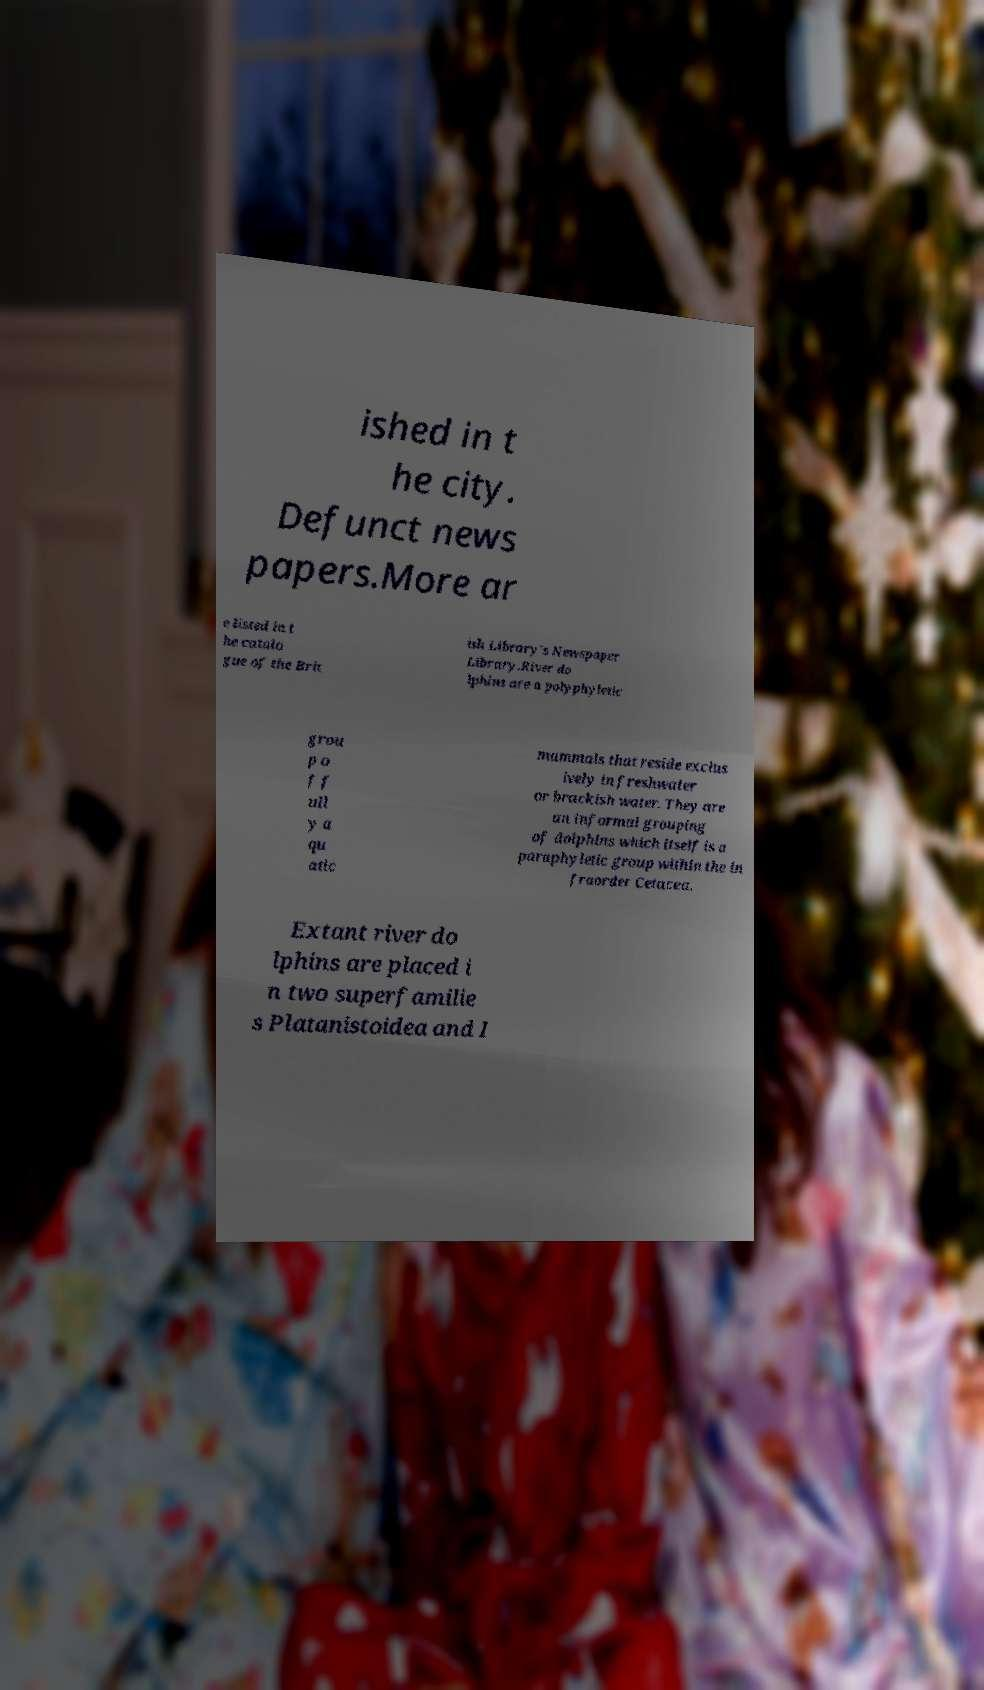For documentation purposes, I need the text within this image transcribed. Could you provide that? ished in t he city. Defunct news papers.More ar e listed in t he catalo gue of the Brit ish Library's Newspaper Library.River do lphins are a polyphyletic grou p o f f ull y a qu atic mammals that reside exclus ively in freshwater or brackish water. They are an informal grouping of dolphins which itself is a paraphyletic group within the in fraorder Cetacea. Extant river do lphins are placed i n two superfamilie s Platanistoidea and I 